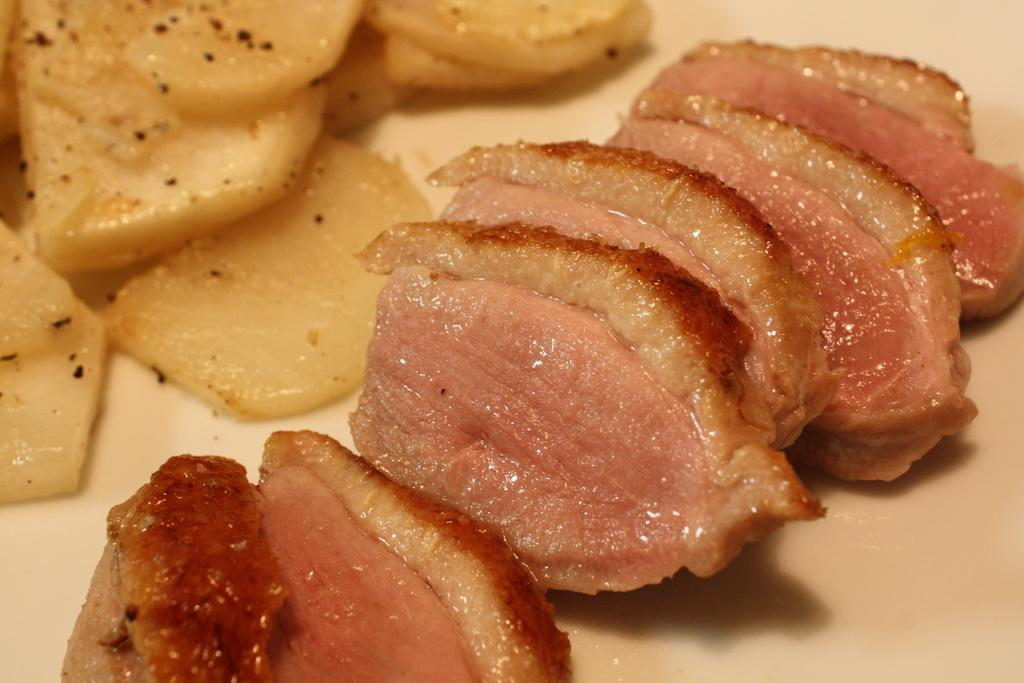What is present on the surface in the image? There is food on the surface in the image. What type of protest is taking place in the image? There is no protest present in the image; it only features food on a surface. What type of basket can be seen holding the food in the image? There is no basket present in the image; it only features food on a surface. 